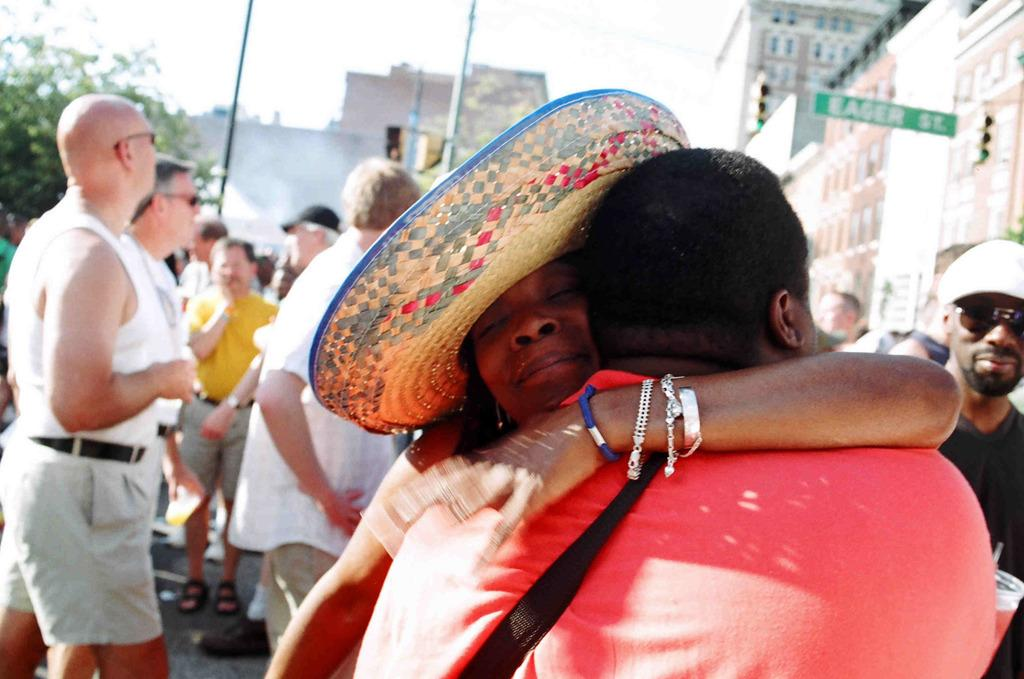What is happening between the two people in the image? The couple is standing and hugging each other in the image. Can you describe the position of the couple in relation to the other people in the image? There are people behind the couple in the image. What can be seen in the background of the image? There are buildings in the background of the image. What type of tool is the carpenter using in the image? There is no carpenter or tool present in the image. How does the toothpaste move around in the image? There is no toothpaste present in the image. 